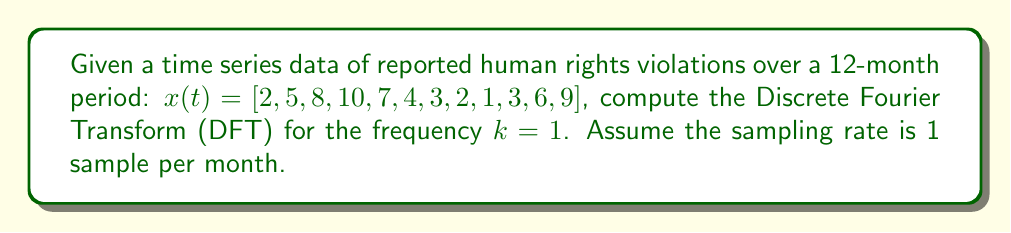Show me your answer to this math problem. To compute the Discrete Fourier Transform (DFT) for the given time series data, we'll use the formula:

$$X(k) = \sum_{n=0}^{N-1} x(n) e^{-i2\pi kn/N}$$

Where:
- $N = 12$ (number of samples)
- $k = 1$ (frequency we're calculating)
- $x(n)$ is our time series data

Step 1: Expand the formula for $k=1$:
$$X(1) = \sum_{n=0}^{11} x(n) e^{-i2\pi n/12}$$

Step 2: Calculate $e^{-i2\pi/12}$ (we'll call this $\omega$):
$$\omega = e^{-i2\pi/12} = \cos(-2\pi/12) + i\sin(-2\pi/12) = \cos(2\pi/12) - i\sin(2\pi/12)$$

Step 3: Calculate each term of the sum:
$$\begin{align*}
x(0) \cdot \omega^0 &= 2 \\
x(1) \cdot \omega^1 &= 5 (\cos(2\pi/12) - i\sin(2\pi/12)) \\
x(2) \cdot \omega^2 &= 8 (\cos(4\pi/12) - i\sin(4\pi/12)) \\
&\vdots \\
x(11) \cdot \omega^{11} &= 9 (\cos(22\pi/12) - i\sin(22\pi/12))
\end{align*}$$

Step 4: Sum all terms:
$$X(1) = 2 + 5(\cos(2\pi/12) - i\sin(2\pi/12)) + ... + 9(\cos(22\pi/12) - i\sin(22\pi/12))$$

Step 5: Simplify the sum (using a calculator or computer):
$$X(1) \approx -6.5 - 7.21i$$

This complex number represents the amplitude and phase of the frequency component $k=1$ in the time series data of human rights violations.
Answer: $X(1) \approx -6.5 - 7.21i$ 